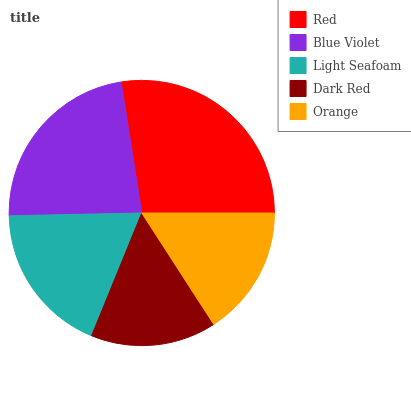Is Dark Red the minimum?
Answer yes or no. Yes. Is Red the maximum?
Answer yes or no. Yes. Is Blue Violet the minimum?
Answer yes or no. No. Is Blue Violet the maximum?
Answer yes or no. No. Is Red greater than Blue Violet?
Answer yes or no. Yes. Is Blue Violet less than Red?
Answer yes or no. Yes. Is Blue Violet greater than Red?
Answer yes or no. No. Is Red less than Blue Violet?
Answer yes or no. No. Is Light Seafoam the high median?
Answer yes or no. Yes. Is Light Seafoam the low median?
Answer yes or no. Yes. Is Dark Red the high median?
Answer yes or no. No. Is Blue Violet the low median?
Answer yes or no. No. 